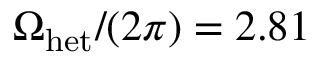Convert formula to latex. <formula><loc_0><loc_0><loc_500><loc_500>\Omega _ { h e t } / ( 2 \pi ) = 2 . 8 1</formula> 